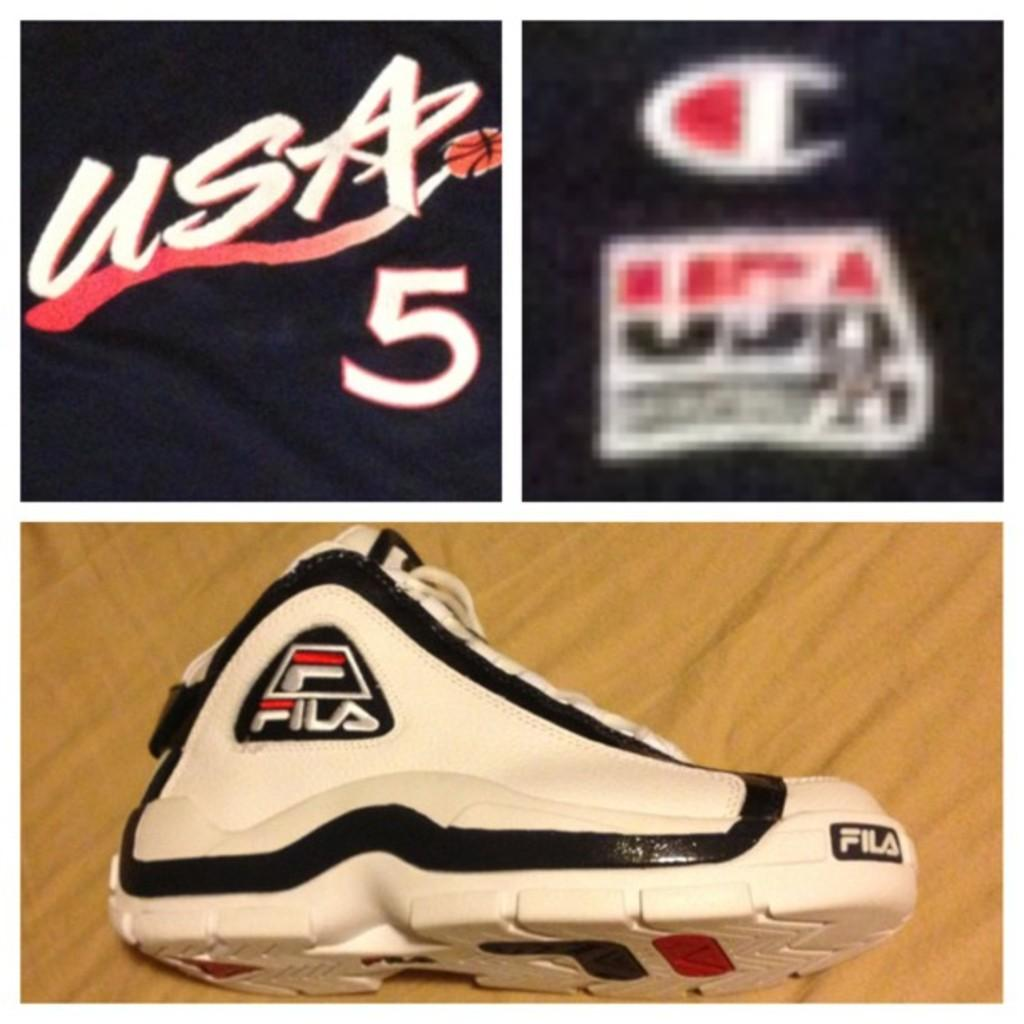<image>
Share a concise interpretation of the image provided. A Fila shoe and  and a USA 5 emblem on an item that is navy in color. 